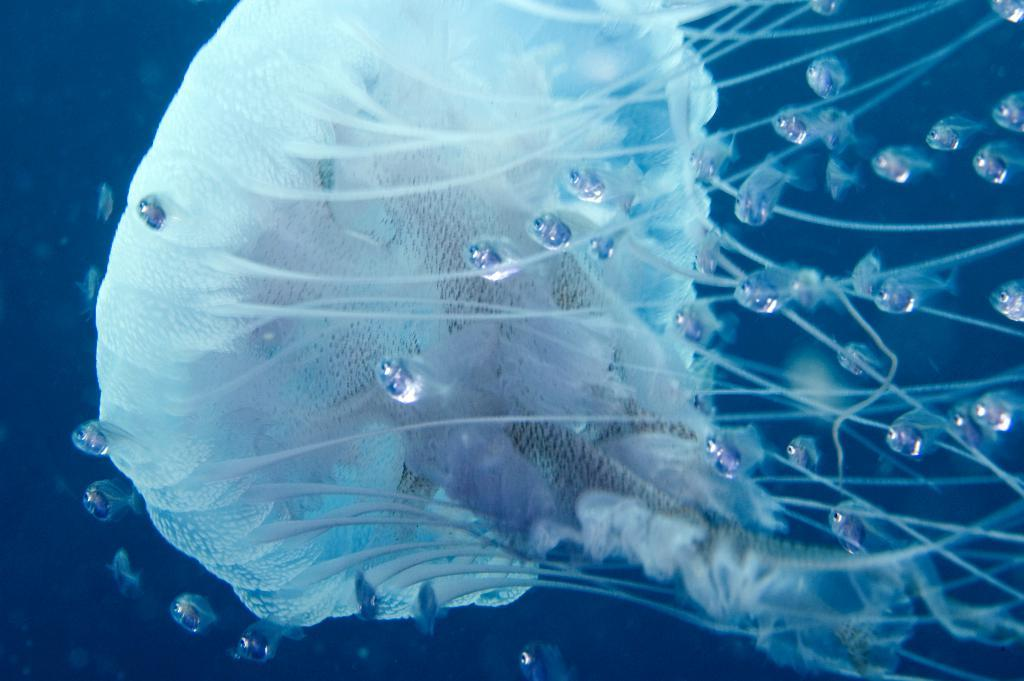What type of sea creature is in the image? There is a jellyfish in the image. Are there any other sea creatures visible in the image? Yes, there are other fishes swimming in the water in the image. What can be seen in the background of the image? The water is visible in the image. What is the condition of the servant in the image? There is no servant present in the image; it features a jellyfish and other fishes swimming in the water. 